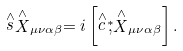Convert formula to latex. <formula><loc_0><loc_0><loc_500><loc_500>\stackrel { \wedge } { s } \stackrel { \wedge } { X } _ { \mu \nu \alpha \beta } = i \left [ \stackrel { \wedge } { c } \stackrel { \ast } { , } \stackrel { \wedge } { X } _ { \mu \nu \alpha \beta } \right ] .</formula> 